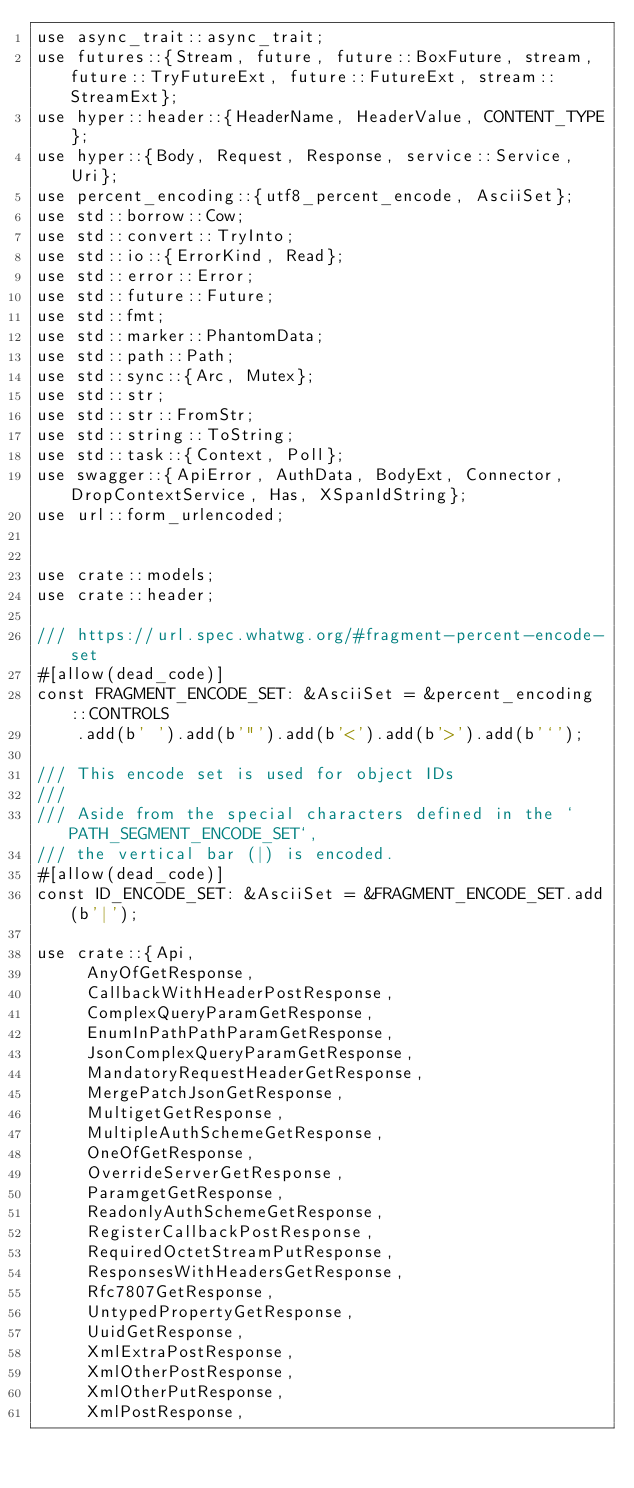Convert code to text. <code><loc_0><loc_0><loc_500><loc_500><_Rust_>use async_trait::async_trait;
use futures::{Stream, future, future::BoxFuture, stream, future::TryFutureExt, future::FutureExt, stream::StreamExt};
use hyper::header::{HeaderName, HeaderValue, CONTENT_TYPE};
use hyper::{Body, Request, Response, service::Service, Uri};
use percent_encoding::{utf8_percent_encode, AsciiSet};
use std::borrow::Cow;
use std::convert::TryInto;
use std::io::{ErrorKind, Read};
use std::error::Error;
use std::future::Future;
use std::fmt;
use std::marker::PhantomData;
use std::path::Path;
use std::sync::{Arc, Mutex};
use std::str;
use std::str::FromStr;
use std::string::ToString;
use std::task::{Context, Poll};
use swagger::{ApiError, AuthData, BodyExt, Connector, DropContextService, Has, XSpanIdString};
use url::form_urlencoded;


use crate::models;
use crate::header;

/// https://url.spec.whatwg.org/#fragment-percent-encode-set
#[allow(dead_code)]
const FRAGMENT_ENCODE_SET: &AsciiSet = &percent_encoding::CONTROLS
    .add(b' ').add(b'"').add(b'<').add(b'>').add(b'`');

/// This encode set is used for object IDs
///
/// Aside from the special characters defined in the `PATH_SEGMENT_ENCODE_SET`,
/// the vertical bar (|) is encoded.
#[allow(dead_code)]
const ID_ENCODE_SET: &AsciiSet = &FRAGMENT_ENCODE_SET.add(b'|');

use crate::{Api,
     AnyOfGetResponse,
     CallbackWithHeaderPostResponse,
     ComplexQueryParamGetResponse,
     EnumInPathPathParamGetResponse,
     JsonComplexQueryParamGetResponse,
     MandatoryRequestHeaderGetResponse,
     MergePatchJsonGetResponse,
     MultigetGetResponse,
     MultipleAuthSchemeGetResponse,
     OneOfGetResponse,
     OverrideServerGetResponse,
     ParamgetGetResponse,
     ReadonlyAuthSchemeGetResponse,
     RegisterCallbackPostResponse,
     RequiredOctetStreamPutResponse,
     ResponsesWithHeadersGetResponse,
     Rfc7807GetResponse,
     UntypedPropertyGetResponse,
     UuidGetResponse,
     XmlExtraPostResponse,
     XmlOtherPostResponse,
     XmlOtherPutResponse,
     XmlPostResponse,</code> 